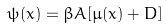<formula> <loc_0><loc_0><loc_500><loc_500>\psi ( x ) = \beta A [ \mu ( x ) + D ]</formula> 